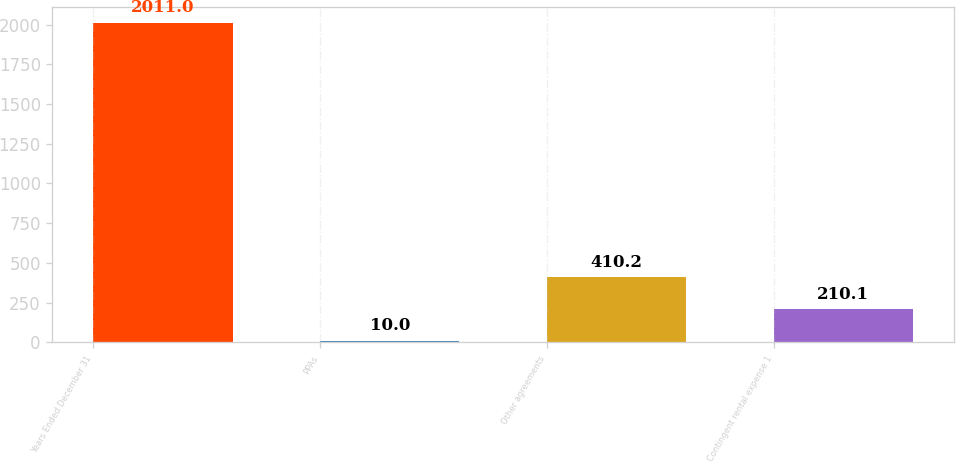<chart> <loc_0><loc_0><loc_500><loc_500><bar_chart><fcel>Years Ended December 31<fcel>PPAs<fcel>Other agreements<fcel>Contingent rental expense 1<nl><fcel>2011<fcel>10<fcel>410.2<fcel>210.1<nl></chart> 